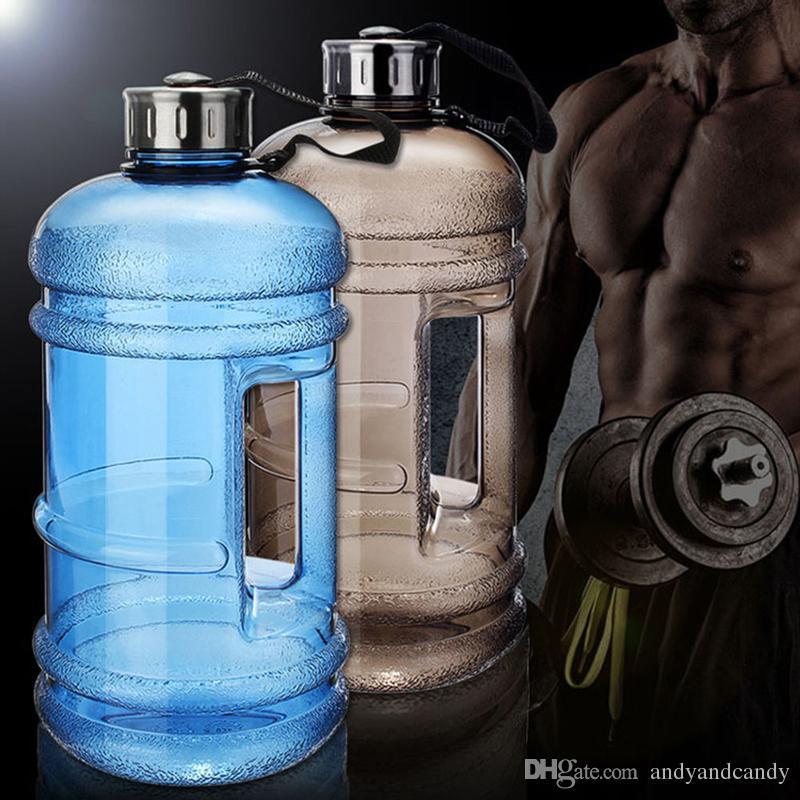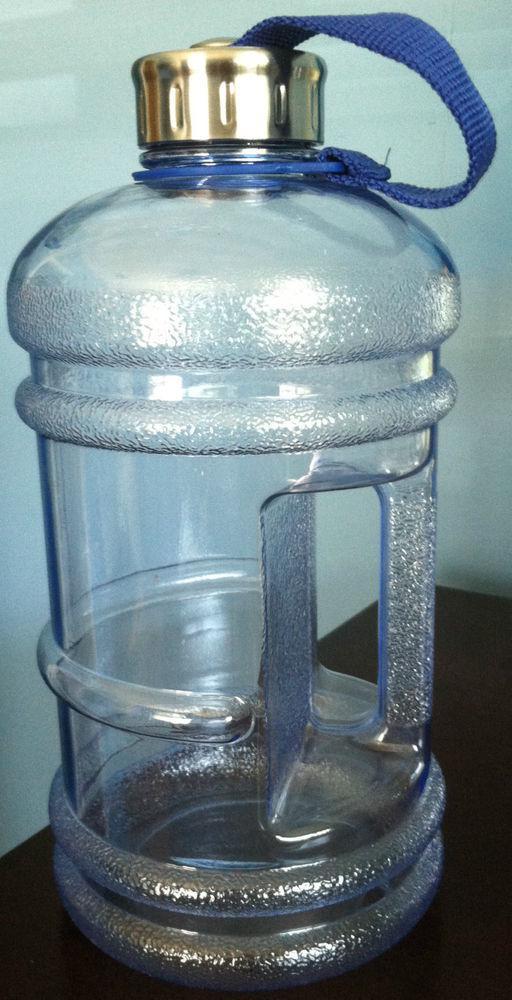The first image is the image on the left, the second image is the image on the right. For the images shown, is this caption "All images feature a single plastic jug." true? Answer yes or no. No. 